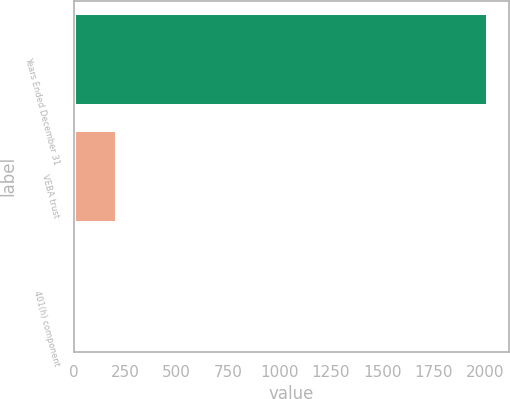<chart> <loc_0><loc_0><loc_500><loc_500><bar_chart><fcel>Years Ended December 31<fcel>VEBA trust<fcel>401(h) component<nl><fcel>2014<fcel>209.5<fcel>9<nl></chart> 